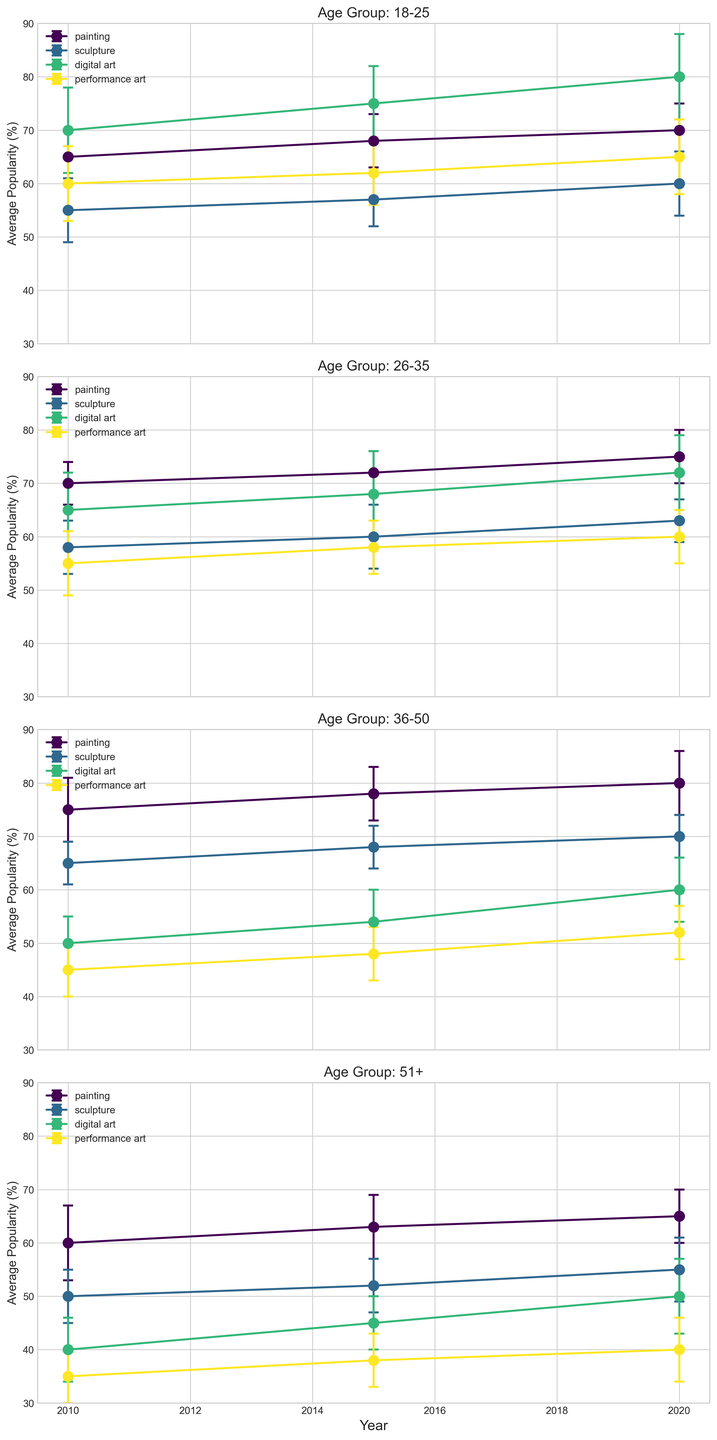What is the average popularity of painting among the 18-25 age group in 2020? To find this, look at the plot corresponding to the age group 18-25 and locate the point for painting in 2020. The popularity value is 70.
Answer: 70 Which art form became the most popular among the 51+ age group by 2020? Locate the 51+ subplot and observe the trend for each art form until the year 2020. Painting has the highest popularity of 65.
Answer: Painting How did the popularity of digital art change from 2010 to 2020 for the 26-35 age group? In the subplot for the 26-35 age group, compare the popularity values of digital art in 2010 (65) and 2020 (72). The popularity increased.
Answer: Increased Among the 36-50 age group, which art form showed the smallest standard deviation in 2020? Check the 36-50 subplot for the standard deviation (length of error bars) in 2020. Sculpture has the smallest error bars, corresponding to a standard deviation of 4.
Answer: Sculpture Which age group saw the greatest increase in the popularity of digital art from 2010 to 2020? For each age group subplot, note the change in digital art's popularity values between 2010 and 2020. The 18-25 age group saw the largest increase from 70 to 80.
Answer: 18-25 For the age group 26-35, did any art form have a decrease in popularity from 2010 to 2020? Look at the 26-35 subplot for the trends from 2010 to 2020. Performance art shows a decrease from 55 to 60.
Answer: No Compare the popularity trends of performance art and digital art in the 18-25 age group from 2010 to 2020. In the subplot for 18-25, observe the popularity trends: Performance art rises from 60 to 65, and digital art increases significantly from 70 to 80.
Answer: Digital art had a sharper increase What was the highest popularity value for sculpture across any age group and year? Locate the highest value for sculpture across all subplots. The maximum value is 70 observed in the 36-50 age group in 2020.
Answer: 70 Which age group had the lowest average popularity for performance art in 2015? In the 2015 year markers in each age group's subplot, compare the popularity values of performance art. The 51+ group has the lowest value at 38.
Answer: 51+ 